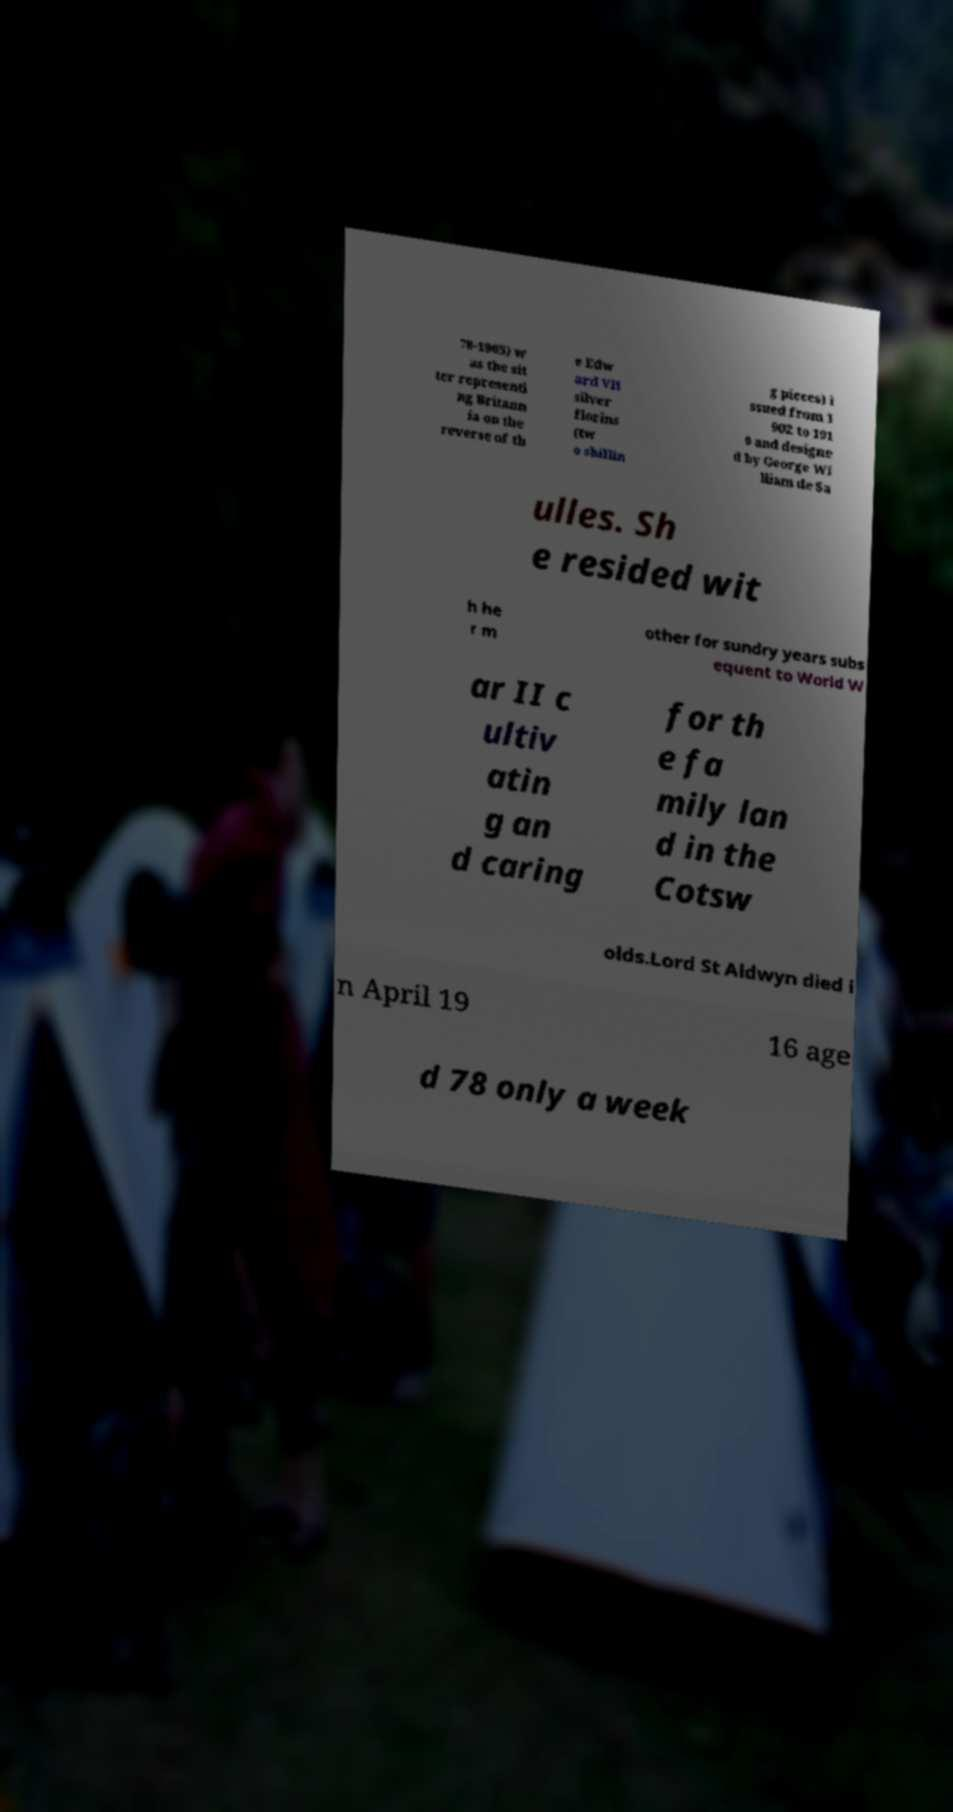There's text embedded in this image that I need extracted. Can you transcribe it verbatim? 78-1965) w as the sit ter representi ng Britann ia on the reverse of th e Edw ard VII silver florins (tw o shillin g pieces) i ssued from 1 902 to 191 0 and designe d by George Wi lliam de Sa ulles. Sh e resided wit h he r m other for sundry years subs equent to World W ar II c ultiv atin g an d caring for th e fa mily lan d in the Cotsw olds.Lord St Aldwyn died i n April 19 16 age d 78 only a week 